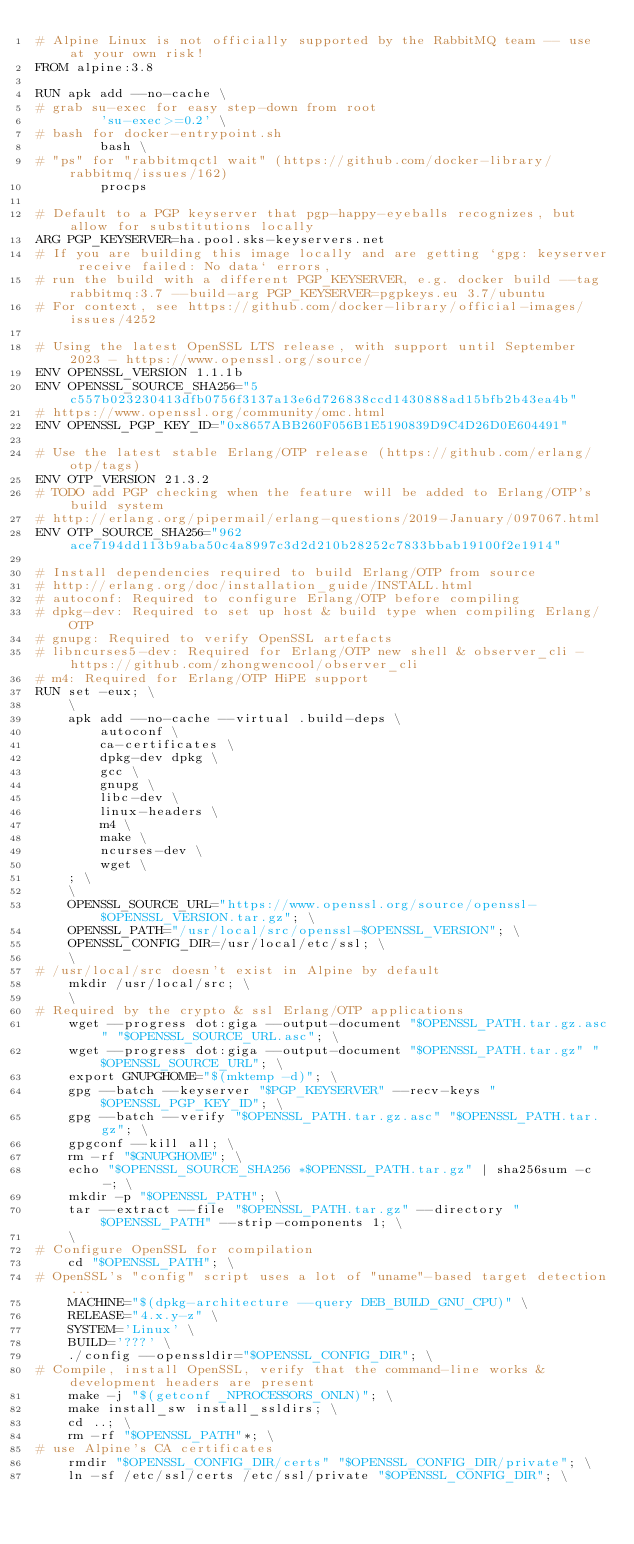Convert code to text. <code><loc_0><loc_0><loc_500><loc_500><_Dockerfile_># Alpine Linux is not officially supported by the RabbitMQ team -- use at your own risk!
FROM alpine:3.8

RUN apk add --no-cache \
# grab su-exec for easy step-down from root
		'su-exec>=0.2' \
# bash for docker-entrypoint.sh
		bash \
# "ps" for "rabbitmqctl wait" (https://github.com/docker-library/rabbitmq/issues/162)
		procps

# Default to a PGP keyserver that pgp-happy-eyeballs recognizes, but allow for substitutions locally
ARG PGP_KEYSERVER=ha.pool.sks-keyservers.net
# If you are building this image locally and are getting `gpg: keyserver receive failed: No data` errors,
# run the build with a different PGP_KEYSERVER, e.g. docker build --tag rabbitmq:3.7 --build-arg PGP_KEYSERVER=pgpkeys.eu 3.7/ubuntu
# For context, see https://github.com/docker-library/official-images/issues/4252

# Using the latest OpenSSL LTS release, with support until September 2023 - https://www.openssl.org/source/
ENV OPENSSL_VERSION 1.1.1b
ENV OPENSSL_SOURCE_SHA256="5c557b023230413dfb0756f3137a13e6d726838ccd1430888ad15bfb2b43ea4b"
# https://www.openssl.org/community/omc.html
ENV OPENSSL_PGP_KEY_ID="0x8657ABB260F056B1E5190839D9C4D26D0E604491"

# Use the latest stable Erlang/OTP release (https://github.com/erlang/otp/tags)
ENV OTP_VERSION 21.3.2
# TODO add PGP checking when the feature will be added to Erlang/OTP's build system
# http://erlang.org/pipermail/erlang-questions/2019-January/097067.html
ENV OTP_SOURCE_SHA256="962ace7194dd113b9aba50c4a8997c3d2d210b28252c7833bbab19100f2e1914"

# Install dependencies required to build Erlang/OTP from source
# http://erlang.org/doc/installation_guide/INSTALL.html
# autoconf: Required to configure Erlang/OTP before compiling
# dpkg-dev: Required to set up host & build type when compiling Erlang/OTP
# gnupg: Required to verify OpenSSL artefacts
# libncurses5-dev: Required for Erlang/OTP new shell & observer_cli - https://github.com/zhongwencool/observer_cli
# m4: Required for Erlang/OTP HiPE support
RUN set -eux; \
	\
	apk add --no-cache --virtual .build-deps \
		autoconf \
		ca-certificates \
		dpkg-dev dpkg \
		gcc \
		gnupg \
		libc-dev \
		linux-headers \
		m4 \
		make \
		ncurses-dev \
		wget \
	; \
	\
	OPENSSL_SOURCE_URL="https://www.openssl.org/source/openssl-$OPENSSL_VERSION.tar.gz"; \
	OPENSSL_PATH="/usr/local/src/openssl-$OPENSSL_VERSION"; \
	OPENSSL_CONFIG_DIR=/usr/local/etc/ssl; \
	\
# /usr/local/src doesn't exist in Alpine by default
	mkdir /usr/local/src; \
	\
# Required by the crypto & ssl Erlang/OTP applications
	wget --progress dot:giga --output-document "$OPENSSL_PATH.tar.gz.asc" "$OPENSSL_SOURCE_URL.asc"; \
	wget --progress dot:giga --output-document "$OPENSSL_PATH.tar.gz" "$OPENSSL_SOURCE_URL"; \
	export GNUPGHOME="$(mktemp -d)"; \
	gpg --batch --keyserver "$PGP_KEYSERVER" --recv-keys "$OPENSSL_PGP_KEY_ID"; \
	gpg --batch --verify "$OPENSSL_PATH.tar.gz.asc" "$OPENSSL_PATH.tar.gz"; \
	gpgconf --kill all; \
	rm -rf "$GNUPGHOME"; \
	echo "$OPENSSL_SOURCE_SHA256 *$OPENSSL_PATH.tar.gz" | sha256sum -c -; \
	mkdir -p "$OPENSSL_PATH"; \
	tar --extract --file "$OPENSSL_PATH.tar.gz" --directory "$OPENSSL_PATH" --strip-components 1; \
	\
# Configure OpenSSL for compilation
	cd "$OPENSSL_PATH"; \
# OpenSSL's "config" script uses a lot of "uname"-based target detection...
	MACHINE="$(dpkg-architecture --query DEB_BUILD_GNU_CPU)" \
	RELEASE="4.x.y-z" \
	SYSTEM='Linux' \
	BUILD='???' \
	./config --openssldir="$OPENSSL_CONFIG_DIR"; \
# Compile, install OpenSSL, verify that the command-line works & development headers are present
	make -j "$(getconf _NPROCESSORS_ONLN)"; \
	make install_sw install_ssldirs; \
	cd ..; \
	rm -rf "$OPENSSL_PATH"*; \
# use Alpine's CA certificates
	rmdir "$OPENSSL_CONFIG_DIR/certs" "$OPENSSL_CONFIG_DIR/private"; \
	ln -sf /etc/ssl/certs /etc/ssl/private "$OPENSSL_CONFIG_DIR"; \</code> 